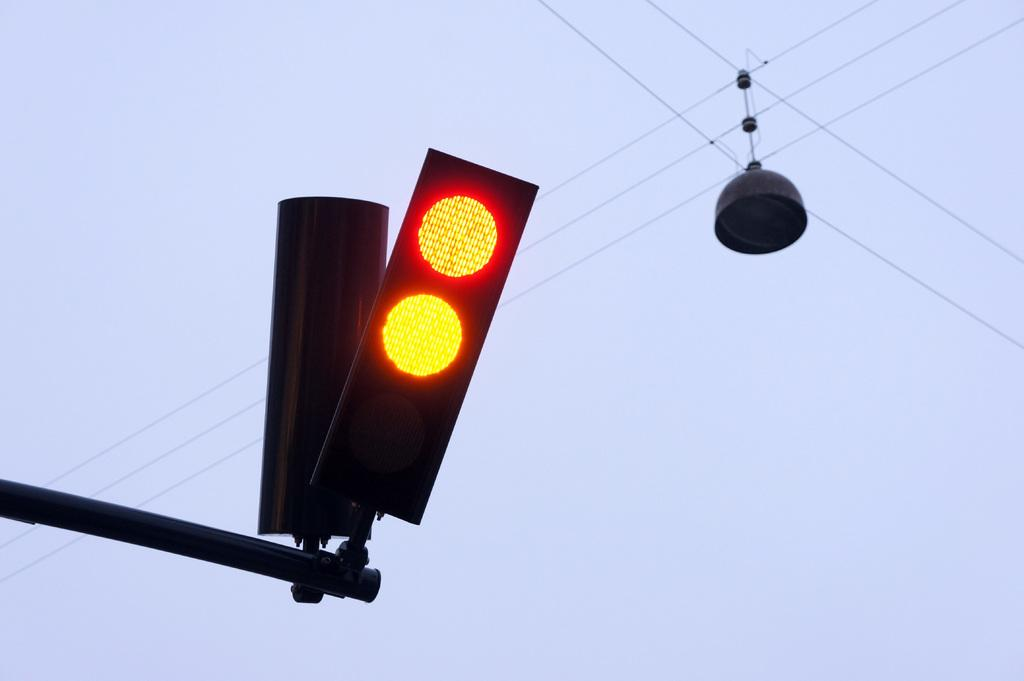What type of signals are present in the image? There are traffic signals in the image. What kind of light can be seen in the image? There is an electric light in the image. What else is present in the image related to electricity? There are electric cables in the image. What can be seen in the background of the image? The sky is visible in the background of the image. Can you tell me how many passengers are in the image? There are no passengers present in the image. What type of animal can be seen interacting with the electric cables in the image? There are no animals present in the image, and the electric cables are not being interacted with. 